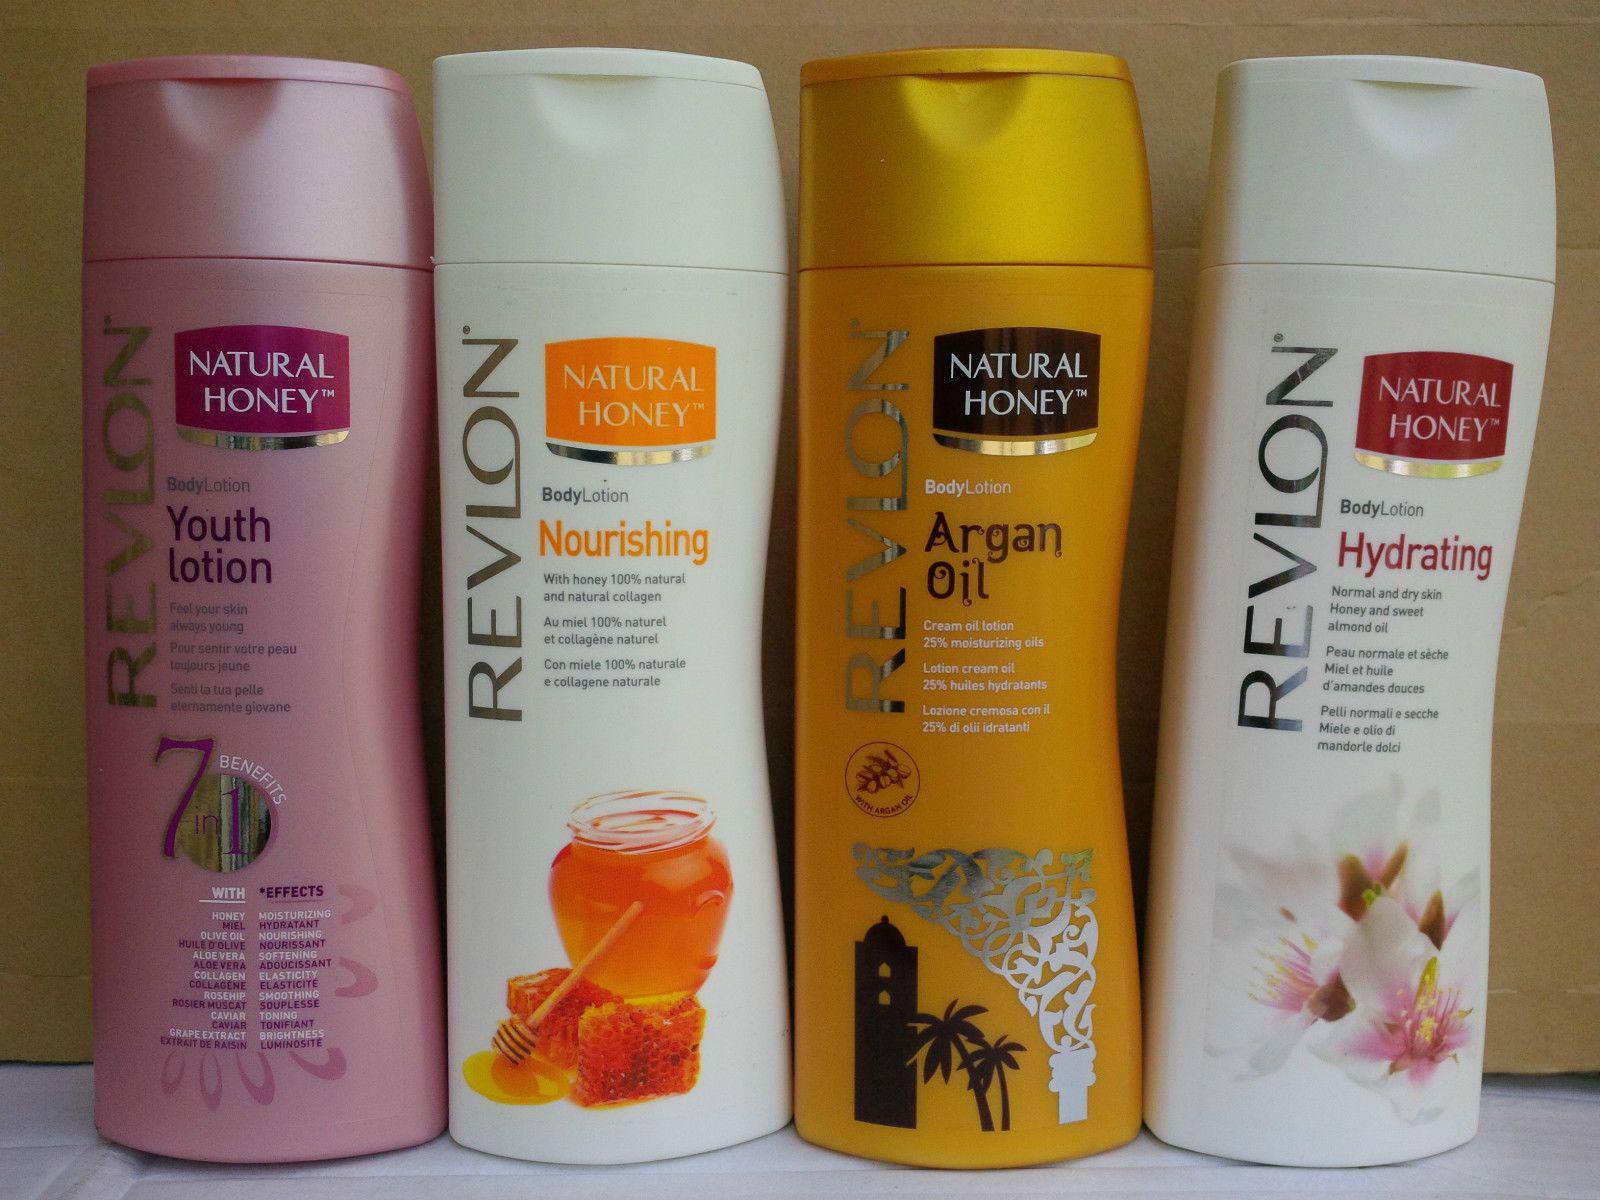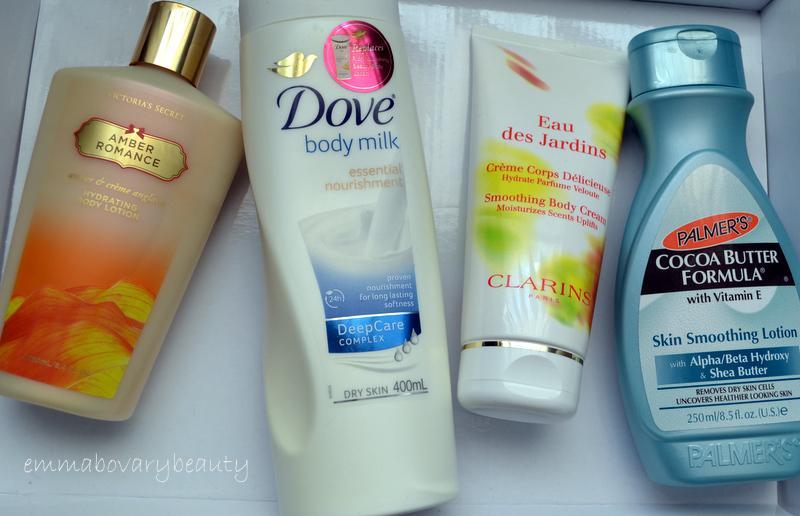The first image is the image on the left, the second image is the image on the right. Examine the images to the left and right. Is the description "There are more items in the right image than in the left image." accurate? Answer yes or no. No. 